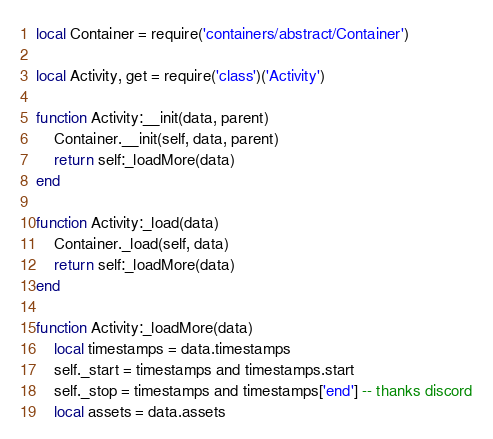Convert code to text. <code><loc_0><loc_0><loc_500><loc_500><_Lua_>local Container = require('containers/abstract/Container')

local Activity, get = require('class')('Activity')

function Activity:__init(data, parent)
	Container.__init(self, data, parent)
	return self:_loadMore(data)
end

function Activity:_load(data)
	Container._load(self, data)
	return self:_loadMore(data)
end

function Activity:_loadMore(data)
	local timestamps = data.timestamps
	self._start = timestamps and timestamps.start
	self._stop = timestamps and timestamps['end'] -- thanks discord
	local assets = data.assets</code> 